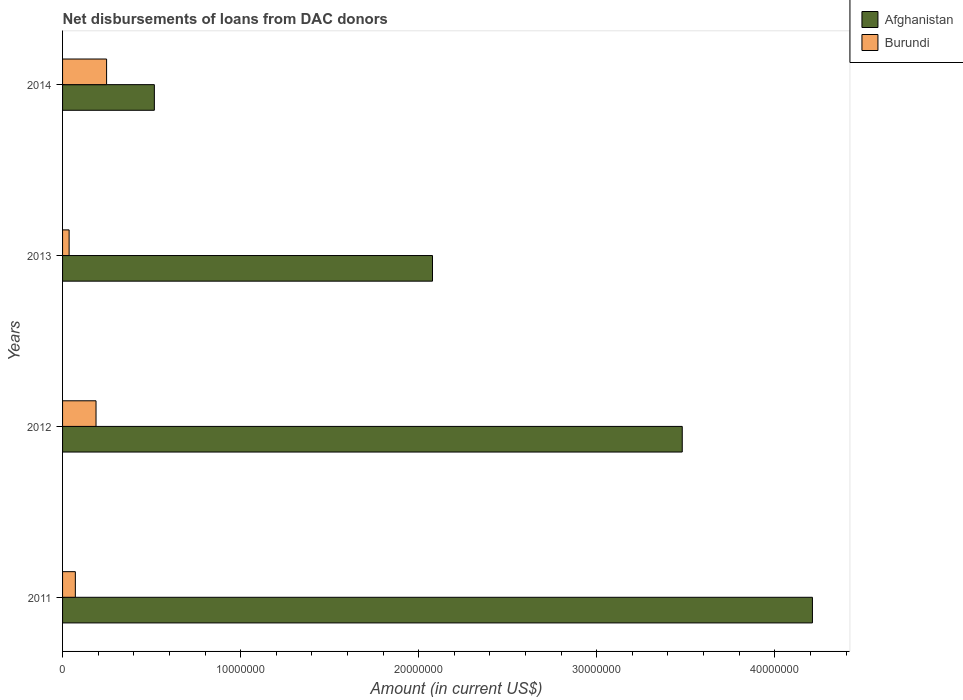How many different coloured bars are there?
Offer a very short reply. 2. Are the number of bars per tick equal to the number of legend labels?
Offer a very short reply. Yes. Are the number of bars on each tick of the Y-axis equal?
Make the answer very short. Yes. How many bars are there on the 1st tick from the bottom?
Ensure brevity in your answer.  2. In how many cases, is the number of bars for a given year not equal to the number of legend labels?
Your response must be concise. 0. What is the amount of loans disbursed in Afghanistan in 2013?
Ensure brevity in your answer.  2.08e+07. Across all years, what is the maximum amount of loans disbursed in Burundi?
Provide a short and direct response. 2.47e+06. Across all years, what is the minimum amount of loans disbursed in Afghanistan?
Your answer should be compact. 5.16e+06. In which year was the amount of loans disbursed in Burundi minimum?
Ensure brevity in your answer.  2013. What is the total amount of loans disbursed in Burundi in the graph?
Ensure brevity in your answer.  5.44e+06. What is the difference between the amount of loans disbursed in Afghanistan in 2011 and that in 2012?
Keep it short and to the point. 7.31e+06. What is the difference between the amount of loans disbursed in Afghanistan in 2011 and the amount of loans disbursed in Burundi in 2014?
Provide a short and direct response. 3.96e+07. What is the average amount of loans disbursed in Burundi per year?
Ensure brevity in your answer.  1.36e+06. In the year 2013, what is the difference between the amount of loans disbursed in Burundi and amount of loans disbursed in Afghanistan?
Keep it short and to the point. -2.04e+07. In how many years, is the amount of loans disbursed in Burundi greater than 26000000 US$?
Ensure brevity in your answer.  0. What is the ratio of the amount of loans disbursed in Burundi in 2011 to that in 2012?
Your answer should be very brief. 0.38. Is the amount of loans disbursed in Burundi in 2013 less than that in 2014?
Provide a short and direct response. Yes. Is the difference between the amount of loans disbursed in Burundi in 2012 and 2013 greater than the difference between the amount of loans disbursed in Afghanistan in 2012 and 2013?
Offer a very short reply. No. What is the difference between the highest and the second highest amount of loans disbursed in Burundi?
Give a very brief answer. 5.94e+05. What is the difference between the highest and the lowest amount of loans disbursed in Burundi?
Offer a terse response. 2.10e+06. In how many years, is the amount of loans disbursed in Burundi greater than the average amount of loans disbursed in Burundi taken over all years?
Offer a very short reply. 2. Is the sum of the amount of loans disbursed in Burundi in 2012 and 2013 greater than the maximum amount of loans disbursed in Afghanistan across all years?
Your answer should be very brief. No. What does the 2nd bar from the top in 2011 represents?
Provide a succinct answer. Afghanistan. What does the 1st bar from the bottom in 2011 represents?
Your response must be concise. Afghanistan. How many bars are there?
Offer a terse response. 8. What is the difference between two consecutive major ticks on the X-axis?
Ensure brevity in your answer.  1.00e+07. Does the graph contain any zero values?
Offer a very short reply. No. Does the graph contain grids?
Ensure brevity in your answer.  No. Where does the legend appear in the graph?
Offer a very short reply. Top right. How many legend labels are there?
Ensure brevity in your answer.  2. What is the title of the graph?
Your response must be concise. Net disbursements of loans from DAC donors. What is the label or title of the X-axis?
Make the answer very short. Amount (in current US$). What is the label or title of the Y-axis?
Provide a succinct answer. Years. What is the Amount (in current US$) in Afghanistan in 2011?
Ensure brevity in your answer.  4.21e+07. What is the Amount (in current US$) of Burundi in 2011?
Give a very brief answer. 7.18e+05. What is the Amount (in current US$) of Afghanistan in 2012?
Offer a terse response. 3.48e+07. What is the Amount (in current US$) in Burundi in 2012?
Provide a short and direct response. 1.88e+06. What is the Amount (in current US$) of Afghanistan in 2013?
Offer a terse response. 2.08e+07. What is the Amount (in current US$) in Burundi in 2013?
Offer a terse response. 3.68e+05. What is the Amount (in current US$) in Afghanistan in 2014?
Provide a short and direct response. 5.16e+06. What is the Amount (in current US$) in Burundi in 2014?
Keep it short and to the point. 2.47e+06. Across all years, what is the maximum Amount (in current US$) of Afghanistan?
Provide a short and direct response. 4.21e+07. Across all years, what is the maximum Amount (in current US$) in Burundi?
Provide a short and direct response. 2.47e+06. Across all years, what is the minimum Amount (in current US$) in Afghanistan?
Your response must be concise. 5.16e+06. Across all years, what is the minimum Amount (in current US$) of Burundi?
Provide a succinct answer. 3.68e+05. What is the total Amount (in current US$) of Afghanistan in the graph?
Offer a very short reply. 1.03e+08. What is the total Amount (in current US$) of Burundi in the graph?
Ensure brevity in your answer.  5.44e+06. What is the difference between the Amount (in current US$) in Afghanistan in 2011 and that in 2012?
Provide a short and direct response. 7.31e+06. What is the difference between the Amount (in current US$) of Burundi in 2011 and that in 2012?
Provide a short and direct response. -1.16e+06. What is the difference between the Amount (in current US$) in Afghanistan in 2011 and that in 2013?
Provide a succinct answer. 2.13e+07. What is the difference between the Amount (in current US$) in Afghanistan in 2011 and that in 2014?
Provide a short and direct response. 3.70e+07. What is the difference between the Amount (in current US$) in Burundi in 2011 and that in 2014?
Offer a terse response. -1.76e+06. What is the difference between the Amount (in current US$) in Afghanistan in 2012 and that in 2013?
Give a very brief answer. 1.40e+07. What is the difference between the Amount (in current US$) of Burundi in 2012 and that in 2013?
Your answer should be very brief. 1.51e+06. What is the difference between the Amount (in current US$) in Afghanistan in 2012 and that in 2014?
Give a very brief answer. 2.96e+07. What is the difference between the Amount (in current US$) in Burundi in 2012 and that in 2014?
Ensure brevity in your answer.  -5.94e+05. What is the difference between the Amount (in current US$) in Afghanistan in 2013 and that in 2014?
Your answer should be compact. 1.56e+07. What is the difference between the Amount (in current US$) of Burundi in 2013 and that in 2014?
Your response must be concise. -2.10e+06. What is the difference between the Amount (in current US$) in Afghanistan in 2011 and the Amount (in current US$) in Burundi in 2012?
Keep it short and to the point. 4.02e+07. What is the difference between the Amount (in current US$) of Afghanistan in 2011 and the Amount (in current US$) of Burundi in 2013?
Make the answer very short. 4.17e+07. What is the difference between the Amount (in current US$) in Afghanistan in 2011 and the Amount (in current US$) in Burundi in 2014?
Keep it short and to the point. 3.96e+07. What is the difference between the Amount (in current US$) of Afghanistan in 2012 and the Amount (in current US$) of Burundi in 2013?
Keep it short and to the point. 3.44e+07. What is the difference between the Amount (in current US$) of Afghanistan in 2012 and the Amount (in current US$) of Burundi in 2014?
Provide a short and direct response. 3.23e+07. What is the difference between the Amount (in current US$) in Afghanistan in 2013 and the Amount (in current US$) in Burundi in 2014?
Offer a terse response. 1.83e+07. What is the average Amount (in current US$) of Afghanistan per year?
Your answer should be compact. 2.57e+07. What is the average Amount (in current US$) of Burundi per year?
Ensure brevity in your answer.  1.36e+06. In the year 2011, what is the difference between the Amount (in current US$) of Afghanistan and Amount (in current US$) of Burundi?
Offer a terse response. 4.14e+07. In the year 2012, what is the difference between the Amount (in current US$) in Afghanistan and Amount (in current US$) in Burundi?
Make the answer very short. 3.29e+07. In the year 2013, what is the difference between the Amount (in current US$) of Afghanistan and Amount (in current US$) of Burundi?
Your answer should be compact. 2.04e+07. In the year 2014, what is the difference between the Amount (in current US$) of Afghanistan and Amount (in current US$) of Burundi?
Ensure brevity in your answer.  2.68e+06. What is the ratio of the Amount (in current US$) in Afghanistan in 2011 to that in 2012?
Give a very brief answer. 1.21. What is the ratio of the Amount (in current US$) of Burundi in 2011 to that in 2012?
Provide a succinct answer. 0.38. What is the ratio of the Amount (in current US$) in Afghanistan in 2011 to that in 2013?
Ensure brevity in your answer.  2.03. What is the ratio of the Amount (in current US$) of Burundi in 2011 to that in 2013?
Your response must be concise. 1.95. What is the ratio of the Amount (in current US$) in Afghanistan in 2011 to that in 2014?
Give a very brief answer. 8.17. What is the ratio of the Amount (in current US$) in Burundi in 2011 to that in 2014?
Give a very brief answer. 0.29. What is the ratio of the Amount (in current US$) in Afghanistan in 2012 to that in 2013?
Give a very brief answer. 1.68. What is the ratio of the Amount (in current US$) in Burundi in 2012 to that in 2013?
Provide a succinct answer. 5.11. What is the ratio of the Amount (in current US$) in Afghanistan in 2012 to that in 2014?
Provide a short and direct response. 6.75. What is the ratio of the Amount (in current US$) in Burundi in 2012 to that in 2014?
Make the answer very short. 0.76. What is the ratio of the Amount (in current US$) of Afghanistan in 2013 to that in 2014?
Your answer should be compact. 4.03. What is the ratio of the Amount (in current US$) of Burundi in 2013 to that in 2014?
Offer a terse response. 0.15. What is the difference between the highest and the second highest Amount (in current US$) in Afghanistan?
Ensure brevity in your answer.  7.31e+06. What is the difference between the highest and the second highest Amount (in current US$) in Burundi?
Provide a succinct answer. 5.94e+05. What is the difference between the highest and the lowest Amount (in current US$) in Afghanistan?
Provide a short and direct response. 3.70e+07. What is the difference between the highest and the lowest Amount (in current US$) of Burundi?
Your answer should be compact. 2.10e+06. 